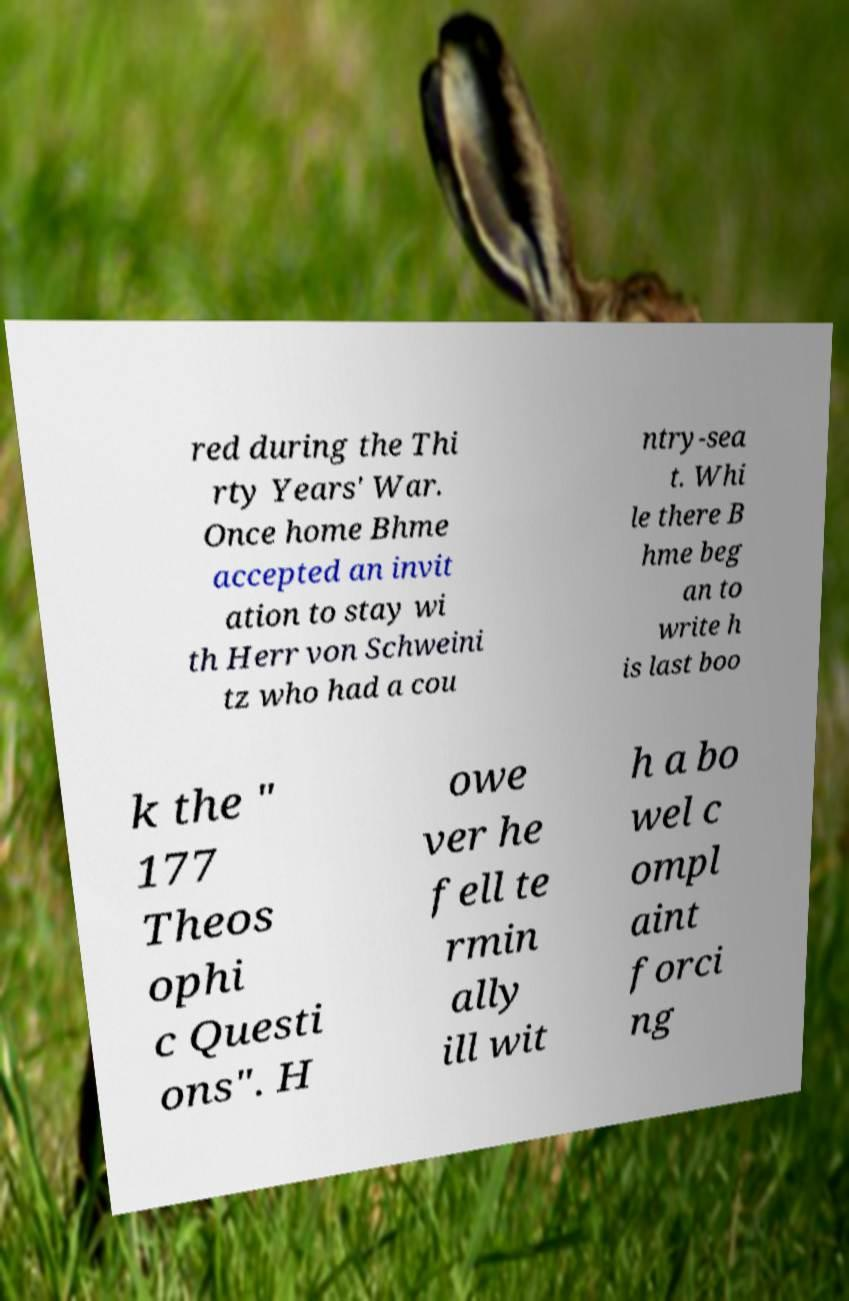Can you read and provide the text displayed in the image?This photo seems to have some interesting text. Can you extract and type it out for me? red during the Thi rty Years' War. Once home Bhme accepted an invit ation to stay wi th Herr von Schweini tz who had a cou ntry-sea t. Whi le there B hme beg an to write h is last boo k the " 177 Theos ophi c Questi ons". H owe ver he fell te rmin ally ill wit h a bo wel c ompl aint forci ng 